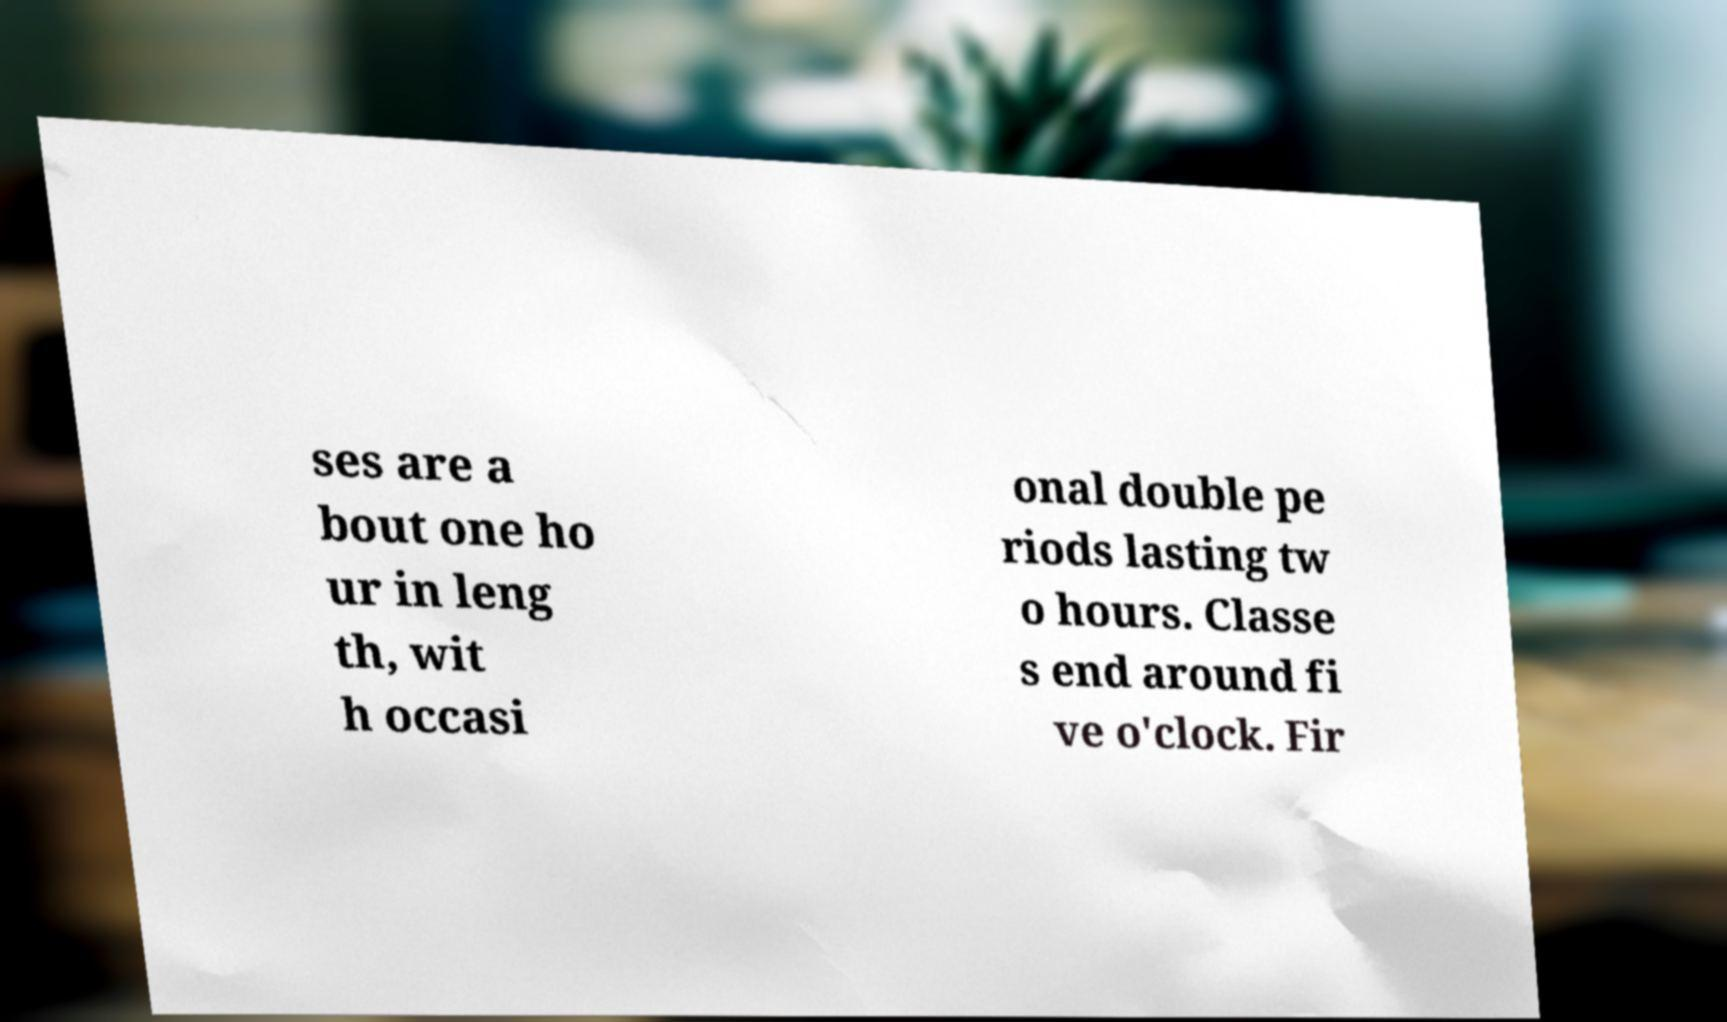Please read and relay the text visible in this image. What does it say? ses are a bout one ho ur in leng th, wit h occasi onal double pe riods lasting tw o hours. Classe s end around fi ve o'clock. Fir 